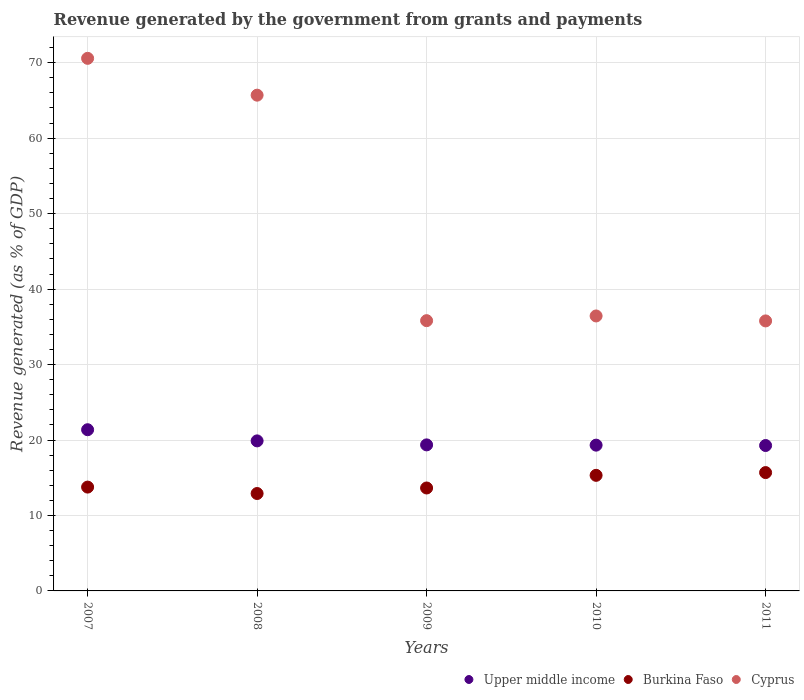How many different coloured dotlines are there?
Provide a short and direct response. 3. What is the revenue generated by the government in Upper middle income in 2011?
Your response must be concise. 19.27. Across all years, what is the maximum revenue generated by the government in Cyprus?
Offer a terse response. 70.58. Across all years, what is the minimum revenue generated by the government in Cyprus?
Give a very brief answer. 35.78. In which year was the revenue generated by the government in Upper middle income maximum?
Offer a terse response. 2007. In which year was the revenue generated by the government in Burkina Faso minimum?
Make the answer very short. 2008. What is the total revenue generated by the government in Upper middle income in the graph?
Provide a short and direct response. 99.19. What is the difference between the revenue generated by the government in Burkina Faso in 2010 and that in 2011?
Keep it short and to the point. -0.37. What is the difference between the revenue generated by the government in Burkina Faso in 2011 and the revenue generated by the government in Upper middle income in 2007?
Give a very brief answer. -5.68. What is the average revenue generated by the government in Cyprus per year?
Ensure brevity in your answer.  48.86. In the year 2007, what is the difference between the revenue generated by the government in Cyprus and revenue generated by the government in Burkina Faso?
Your answer should be compact. 56.82. What is the ratio of the revenue generated by the government in Upper middle income in 2007 to that in 2008?
Make the answer very short. 1.07. Is the revenue generated by the government in Upper middle income in 2007 less than that in 2010?
Your answer should be very brief. No. What is the difference between the highest and the second highest revenue generated by the government in Cyprus?
Make the answer very short. 4.88. What is the difference between the highest and the lowest revenue generated by the government in Upper middle income?
Ensure brevity in your answer.  2.09. In how many years, is the revenue generated by the government in Upper middle income greater than the average revenue generated by the government in Upper middle income taken over all years?
Your answer should be very brief. 2. Is it the case that in every year, the sum of the revenue generated by the government in Burkina Faso and revenue generated by the government in Upper middle income  is greater than the revenue generated by the government in Cyprus?
Provide a succinct answer. No. Is the revenue generated by the government in Burkina Faso strictly less than the revenue generated by the government in Cyprus over the years?
Provide a succinct answer. Yes. How many years are there in the graph?
Offer a very short reply. 5. What is the difference between two consecutive major ticks on the Y-axis?
Provide a short and direct response. 10. Are the values on the major ticks of Y-axis written in scientific E-notation?
Give a very brief answer. No. Does the graph contain any zero values?
Keep it short and to the point. No. How many legend labels are there?
Your response must be concise. 3. How are the legend labels stacked?
Your response must be concise. Horizontal. What is the title of the graph?
Make the answer very short. Revenue generated by the government from grants and payments. What is the label or title of the X-axis?
Your response must be concise. Years. What is the label or title of the Y-axis?
Offer a terse response. Revenue generated (as % of GDP). What is the Revenue generated (as % of GDP) of Upper middle income in 2007?
Provide a succinct answer. 21.36. What is the Revenue generated (as % of GDP) in Burkina Faso in 2007?
Offer a very short reply. 13.76. What is the Revenue generated (as % of GDP) in Cyprus in 2007?
Provide a succinct answer. 70.58. What is the Revenue generated (as % of GDP) of Upper middle income in 2008?
Provide a succinct answer. 19.88. What is the Revenue generated (as % of GDP) in Burkina Faso in 2008?
Your answer should be very brief. 12.91. What is the Revenue generated (as % of GDP) of Cyprus in 2008?
Your response must be concise. 65.7. What is the Revenue generated (as % of GDP) of Upper middle income in 2009?
Keep it short and to the point. 19.35. What is the Revenue generated (as % of GDP) of Burkina Faso in 2009?
Make the answer very short. 13.64. What is the Revenue generated (as % of GDP) in Cyprus in 2009?
Offer a very short reply. 35.82. What is the Revenue generated (as % of GDP) of Upper middle income in 2010?
Provide a short and direct response. 19.32. What is the Revenue generated (as % of GDP) in Burkina Faso in 2010?
Provide a short and direct response. 15.32. What is the Revenue generated (as % of GDP) in Cyprus in 2010?
Offer a terse response. 36.44. What is the Revenue generated (as % of GDP) of Upper middle income in 2011?
Ensure brevity in your answer.  19.27. What is the Revenue generated (as % of GDP) in Burkina Faso in 2011?
Offer a very short reply. 15.68. What is the Revenue generated (as % of GDP) in Cyprus in 2011?
Offer a terse response. 35.78. Across all years, what is the maximum Revenue generated (as % of GDP) of Upper middle income?
Your response must be concise. 21.36. Across all years, what is the maximum Revenue generated (as % of GDP) in Burkina Faso?
Provide a short and direct response. 15.68. Across all years, what is the maximum Revenue generated (as % of GDP) of Cyprus?
Ensure brevity in your answer.  70.58. Across all years, what is the minimum Revenue generated (as % of GDP) of Upper middle income?
Ensure brevity in your answer.  19.27. Across all years, what is the minimum Revenue generated (as % of GDP) of Burkina Faso?
Keep it short and to the point. 12.91. Across all years, what is the minimum Revenue generated (as % of GDP) of Cyprus?
Provide a short and direct response. 35.78. What is the total Revenue generated (as % of GDP) of Upper middle income in the graph?
Give a very brief answer. 99.19. What is the total Revenue generated (as % of GDP) of Burkina Faso in the graph?
Provide a short and direct response. 71.31. What is the total Revenue generated (as % of GDP) in Cyprus in the graph?
Offer a terse response. 244.32. What is the difference between the Revenue generated (as % of GDP) of Upper middle income in 2007 and that in 2008?
Your answer should be very brief. 1.48. What is the difference between the Revenue generated (as % of GDP) of Burkina Faso in 2007 and that in 2008?
Give a very brief answer. 0.85. What is the difference between the Revenue generated (as % of GDP) in Cyprus in 2007 and that in 2008?
Keep it short and to the point. 4.88. What is the difference between the Revenue generated (as % of GDP) in Upper middle income in 2007 and that in 2009?
Keep it short and to the point. 2.01. What is the difference between the Revenue generated (as % of GDP) of Burkina Faso in 2007 and that in 2009?
Offer a very short reply. 0.12. What is the difference between the Revenue generated (as % of GDP) of Cyprus in 2007 and that in 2009?
Provide a succinct answer. 34.77. What is the difference between the Revenue generated (as % of GDP) in Upper middle income in 2007 and that in 2010?
Provide a short and direct response. 2.04. What is the difference between the Revenue generated (as % of GDP) in Burkina Faso in 2007 and that in 2010?
Provide a succinct answer. -1.56. What is the difference between the Revenue generated (as % of GDP) in Cyprus in 2007 and that in 2010?
Your answer should be compact. 34.14. What is the difference between the Revenue generated (as % of GDP) in Upper middle income in 2007 and that in 2011?
Provide a succinct answer. 2.09. What is the difference between the Revenue generated (as % of GDP) of Burkina Faso in 2007 and that in 2011?
Offer a very short reply. -1.92. What is the difference between the Revenue generated (as % of GDP) in Cyprus in 2007 and that in 2011?
Ensure brevity in your answer.  34.8. What is the difference between the Revenue generated (as % of GDP) in Upper middle income in 2008 and that in 2009?
Make the answer very short. 0.53. What is the difference between the Revenue generated (as % of GDP) in Burkina Faso in 2008 and that in 2009?
Ensure brevity in your answer.  -0.73. What is the difference between the Revenue generated (as % of GDP) of Cyprus in 2008 and that in 2009?
Offer a very short reply. 29.88. What is the difference between the Revenue generated (as % of GDP) of Upper middle income in 2008 and that in 2010?
Provide a succinct answer. 0.56. What is the difference between the Revenue generated (as % of GDP) of Burkina Faso in 2008 and that in 2010?
Your answer should be compact. -2.41. What is the difference between the Revenue generated (as % of GDP) of Cyprus in 2008 and that in 2010?
Ensure brevity in your answer.  29.26. What is the difference between the Revenue generated (as % of GDP) in Upper middle income in 2008 and that in 2011?
Your answer should be very brief. 0.61. What is the difference between the Revenue generated (as % of GDP) of Burkina Faso in 2008 and that in 2011?
Keep it short and to the point. -2.77. What is the difference between the Revenue generated (as % of GDP) of Cyprus in 2008 and that in 2011?
Your answer should be very brief. 29.92. What is the difference between the Revenue generated (as % of GDP) in Upper middle income in 2009 and that in 2010?
Provide a short and direct response. 0.04. What is the difference between the Revenue generated (as % of GDP) of Burkina Faso in 2009 and that in 2010?
Your response must be concise. -1.68. What is the difference between the Revenue generated (as % of GDP) of Cyprus in 2009 and that in 2010?
Provide a short and direct response. -0.62. What is the difference between the Revenue generated (as % of GDP) in Upper middle income in 2009 and that in 2011?
Make the answer very short. 0.09. What is the difference between the Revenue generated (as % of GDP) in Burkina Faso in 2009 and that in 2011?
Make the answer very short. -2.04. What is the difference between the Revenue generated (as % of GDP) of Cyprus in 2009 and that in 2011?
Provide a succinct answer. 0.03. What is the difference between the Revenue generated (as % of GDP) in Upper middle income in 2010 and that in 2011?
Make the answer very short. 0.05. What is the difference between the Revenue generated (as % of GDP) of Burkina Faso in 2010 and that in 2011?
Offer a terse response. -0.37. What is the difference between the Revenue generated (as % of GDP) of Cyprus in 2010 and that in 2011?
Keep it short and to the point. 0.66. What is the difference between the Revenue generated (as % of GDP) of Upper middle income in 2007 and the Revenue generated (as % of GDP) of Burkina Faso in 2008?
Your response must be concise. 8.45. What is the difference between the Revenue generated (as % of GDP) of Upper middle income in 2007 and the Revenue generated (as % of GDP) of Cyprus in 2008?
Make the answer very short. -44.34. What is the difference between the Revenue generated (as % of GDP) in Burkina Faso in 2007 and the Revenue generated (as % of GDP) in Cyprus in 2008?
Your response must be concise. -51.94. What is the difference between the Revenue generated (as % of GDP) in Upper middle income in 2007 and the Revenue generated (as % of GDP) in Burkina Faso in 2009?
Provide a short and direct response. 7.72. What is the difference between the Revenue generated (as % of GDP) of Upper middle income in 2007 and the Revenue generated (as % of GDP) of Cyprus in 2009?
Your response must be concise. -14.45. What is the difference between the Revenue generated (as % of GDP) of Burkina Faso in 2007 and the Revenue generated (as % of GDP) of Cyprus in 2009?
Provide a succinct answer. -22.06. What is the difference between the Revenue generated (as % of GDP) of Upper middle income in 2007 and the Revenue generated (as % of GDP) of Burkina Faso in 2010?
Your answer should be compact. 6.04. What is the difference between the Revenue generated (as % of GDP) in Upper middle income in 2007 and the Revenue generated (as % of GDP) in Cyprus in 2010?
Make the answer very short. -15.08. What is the difference between the Revenue generated (as % of GDP) of Burkina Faso in 2007 and the Revenue generated (as % of GDP) of Cyprus in 2010?
Offer a terse response. -22.68. What is the difference between the Revenue generated (as % of GDP) of Upper middle income in 2007 and the Revenue generated (as % of GDP) of Burkina Faso in 2011?
Your answer should be compact. 5.68. What is the difference between the Revenue generated (as % of GDP) in Upper middle income in 2007 and the Revenue generated (as % of GDP) in Cyprus in 2011?
Give a very brief answer. -14.42. What is the difference between the Revenue generated (as % of GDP) of Burkina Faso in 2007 and the Revenue generated (as % of GDP) of Cyprus in 2011?
Offer a very short reply. -22.02. What is the difference between the Revenue generated (as % of GDP) in Upper middle income in 2008 and the Revenue generated (as % of GDP) in Burkina Faso in 2009?
Provide a short and direct response. 6.24. What is the difference between the Revenue generated (as % of GDP) of Upper middle income in 2008 and the Revenue generated (as % of GDP) of Cyprus in 2009?
Offer a very short reply. -15.93. What is the difference between the Revenue generated (as % of GDP) in Burkina Faso in 2008 and the Revenue generated (as % of GDP) in Cyprus in 2009?
Keep it short and to the point. -22.91. What is the difference between the Revenue generated (as % of GDP) in Upper middle income in 2008 and the Revenue generated (as % of GDP) in Burkina Faso in 2010?
Provide a succinct answer. 4.57. What is the difference between the Revenue generated (as % of GDP) of Upper middle income in 2008 and the Revenue generated (as % of GDP) of Cyprus in 2010?
Provide a succinct answer. -16.56. What is the difference between the Revenue generated (as % of GDP) in Burkina Faso in 2008 and the Revenue generated (as % of GDP) in Cyprus in 2010?
Give a very brief answer. -23.53. What is the difference between the Revenue generated (as % of GDP) of Upper middle income in 2008 and the Revenue generated (as % of GDP) of Burkina Faso in 2011?
Your answer should be compact. 4.2. What is the difference between the Revenue generated (as % of GDP) in Upper middle income in 2008 and the Revenue generated (as % of GDP) in Cyprus in 2011?
Make the answer very short. -15.9. What is the difference between the Revenue generated (as % of GDP) in Burkina Faso in 2008 and the Revenue generated (as % of GDP) in Cyprus in 2011?
Your response must be concise. -22.87. What is the difference between the Revenue generated (as % of GDP) in Upper middle income in 2009 and the Revenue generated (as % of GDP) in Burkina Faso in 2010?
Your answer should be compact. 4.04. What is the difference between the Revenue generated (as % of GDP) of Upper middle income in 2009 and the Revenue generated (as % of GDP) of Cyprus in 2010?
Offer a very short reply. -17.09. What is the difference between the Revenue generated (as % of GDP) in Burkina Faso in 2009 and the Revenue generated (as % of GDP) in Cyprus in 2010?
Offer a terse response. -22.8. What is the difference between the Revenue generated (as % of GDP) in Upper middle income in 2009 and the Revenue generated (as % of GDP) in Burkina Faso in 2011?
Provide a short and direct response. 3.67. What is the difference between the Revenue generated (as % of GDP) of Upper middle income in 2009 and the Revenue generated (as % of GDP) of Cyprus in 2011?
Ensure brevity in your answer.  -16.43. What is the difference between the Revenue generated (as % of GDP) in Burkina Faso in 2009 and the Revenue generated (as % of GDP) in Cyprus in 2011?
Give a very brief answer. -22.14. What is the difference between the Revenue generated (as % of GDP) in Upper middle income in 2010 and the Revenue generated (as % of GDP) in Burkina Faso in 2011?
Provide a succinct answer. 3.64. What is the difference between the Revenue generated (as % of GDP) in Upper middle income in 2010 and the Revenue generated (as % of GDP) in Cyprus in 2011?
Your answer should be compact. -16.46. What is the difference between the Revenue generated (as % of GDP) in Burkina Faso in 2010 and the Revenue generated (as % of GDP) in Cyprus in 2011?
Offer a terse response. -20.46. What is the average Revenue generated (as % of GDP) of Upper middle income per year?
Offer a very short reply. 19.84. What is the average Revenue generated (as % of GDP) in Burkina Faso per year?
Give a very brief answer. 14.26. What is the average Revenue generated (as % of GDP) of Cyprus per year?
Your response must be concise. 48.86. In the year 2007, what is the difference between the Revenue generated (as % of GDP) of Upper middle income and Revenue generated (as % of GDP) of Burkina Faso?
Your response must be concise. 7.6. In the year 2007, what is the difference between the Revenue generated (as % of GDP) in Upper middle income and Revenue generated (as % of GDP) in Cyprus?
Your answer should be very brief. -49.22. In the year 2007, what is the difference between the Revenue generated (as % of GDP) of Burkina Faso and Revenue generated (as % of GDP) of Cyprus?
Your answer should be compact. -56.82. In the year 2008, what is the difference between the Revenue generated (as % of GDP) of Upper middle income and Revenue generated (as % of GDP) of Burkina Faso?
Your response must be concise. 6.97. In the year 2008, what is the difference between the Revenue generated (as % of GDP) of Upper middle income and Revenue generated (as % of GDP) of Cyprus?
Make the answer very short. -45.82. In the year 2008, what is the difference between the Revenue generated (as % of GDP) in Burkina Faso and Revenue generated (as % of GDP) in Cyprus?
Your response must be concise. -52.79. In the year 2009, what is the difference between the Revenue generated (as % of GDP) of Upper middle income and Revenue generated (as % of GDP) of Burkina Faso?
Provide a short and direct response. 5.71. In the year 2009, what is the difference between the Revenue generated (as % of GDP) in Upper middle income and Revenue generated (as % of GDP) in Cyprus?
Your response must be concise. -16.46. In the year 2009, what is the difference between the Revenue generated (as % of GDP) in Burkina Faso and Revenue generated (as % of GDP) in Cyprus?
Provide a short and direct response. -22.17. In the year 2010, what is the difference between the Revenue generated (as % of GDP) of Upper middle income and Revenue generated (as % of GDP) of Burkina Faso?
Your answer should be compact. 4. In the year 2010, what is the difference between the Revenue generated (as % of GDP) in Upper middle income and Revenue generated (as % of GDP) in Cyprus?
Your answer should be compact. -17.12. In the year 2010, what is the difference between the Revenue generated (as % of GDP) of Burkina Faso and Revenue generated (as % of GDP) of Cyprus?
Provide a succinct answer. -21.12. In the year 2011, what is the difference between the Revenue generated (as % of GDP) in Upper middle income and Revenue generated (as % of GDP) in Burkina Faso?
Ensure brevity in your answer.  3.59. In the year 2011, what is the difference between the Revenue generated (as % of GDP) of Upper middle income and Revenue generated (as % of GDP) of Cyprus?
Make the answer very short. -16.51. In the year 2011, what is the difference between the Revenue generated (as % of GDP) in Burkina Faso and Revenue generated (as % of GDP) in Cyprus?
Provide a succinct answer. -20.1. What is the ratio of the Revenue generated (as % of GDP) of Upper middle income in 2007 to that in 2008?
Your answer should be very brief. 1.07. What is the ratio of the Revenue generated (as % of GDP) in Burkina Faso in 2007 to that in 2008?
Provide a short and direct response. 1.07. What is the ratio of the Revenue generated (as % of GDP) of Cyprus in 2007 to that in 2008?
Make the answer very short. 1.07. What is the ratio of the Revenue generated (as % of GDP) in Upper middle income in 2007 to that in 2009?
Ensure brevity in your answer.  1.1. What is the ratio of the Revenue generated (as % of GDP) in Burkina Faso in 2007 to that in 2009?
Ensure brevity in your answer.  1.01. What is the ratio of the Revenue generated (as % of GDP) in Cyprus in 2007 to that in 2009?
Offer a very short reply. 1.97. What is the ratio of the Revenue generated (as % of GDP) of Upper middle income in 2007 to that in 2010?
Make the answer very short. 1.11. What is the ratio of the Revenue generated (as % of GDP) in Burkina Faso in 2007 to that in 2010?
Provide a succinct answer. 0.9. What is the ratio of the Revenue generated (as % of GDP) of Cyprus in 2007 to that in 2010?
Offer a terse response. 1.94. What is the ratio of the Revenue generated (as % of GDP) in Upper middle income in 2007 to that in 2011?
Ensure brevity in your answer.  1.11. What is the ratio of the Revenue generated (as % of GDP) in Burkina Faso in 2007 to that in 2011?
Make the answer very short. 0.88. What is the ratio of the Revenue generated (as % of GDP) of Cyprus in 2007 to that in 2011?
Give a very brief answer. 1.97. What is the ratio of the Revenue generated (as % of GDP) of Upper middle income in 2008 to that in 2009?
Your answer should be compact. 1.03. What is the ratio of the Revenue generated (as % of GDP) in Burkina Faso in 2008 to that in 2009?
Offer a terse response. 0.95. What is the ratio of the Revenue generated (as % of GDP) in Cyprus in 2008 to that in 2009?
Provide a short and direct response. 1.83. What is the ratio of the Revenue generated (as % of GDP) in Upper middle income in 2008 to that in 2010?
Your answer should be very brief. 1.03. What is the ratio of the Revenue generated (as % of GDP) in Burkina Faso in 2008 to that in 2010?
Make the answer very short. 0.84. What is the ratio of the Revenue generated (as % of GDP) of Cyprus in 2008 to that in 2010?
Offer a terse response. 1.8. What is the ratio of the Revenue generated (as % of GDP) of Upper middle income in 2008 to that in 2011?
Your response must be concise. 1.03. What is the ratio of the Revenue generated (as % of GDP) in Burkina Faso in 2008 to that in 2011?
Offer a terse response. 0.82. What is the ratio of the Revenue generated (as % of GDP) of Cyprus in 2008 to that in 2011?
Provide a succinct answer. 1.84. What is the ratio of the Revenue generated (as % of GDP) of Upper middle income in 2009 to that in 2010?
Offer a very short reply. 1. What is the ratio of the Revenue generated (as % of GDP) in Burkina Faso in 2009 to that in 2010?
Provide a succinct answer. 0.89. What is the ratio of the Revenue generated (as % of GDP) of Cyprus in 2009 to that in 2010?
Your answer should be compact. 0.98. What is the ratio of the Revenue generated (as % of GDP) in Upper middle income in 2009 to that in 2011?
Provide a short and direct response. 1. What is the ratio of the Revenue generated (as % of GDP) in Burkina Faso in 2009 to that in 2011?
Keep it short and to the point. 0.87. What is the ratio of the Revenue generated (as % of GDP) in Upper middle income in 2010 to that in 2011?
Ensure brevity in your answer.  1. What is the ratio of the Revenue generated (as % of GDP) in Burkina Faso in 2010 to that in 2011?
Offer a very short reply. 0.98. What is the ratio of the Revenue generated (as % of GDP) of Cyprus in 2010 to that in 2011?
Your answer should be very brief. 1.02. What is the difference between the highest and the second highest Revenue generated (as % of GDP) of Upper middle income?
Make the answer very short. 1.48. What is the difference between the highest and the second highest Revenue generated (as % of GDP) in Burkina Faso?
Your answer should be compact. 0.37. What is the difference between the highest and the second highest Revenue generated (as % of GDP) in Cyprus?
Ensure brevity in your answer.  4.88. What is the difference between the highest and the lowest Revenue generated (as % of GDP) in Upper middle income?
Give a very brief answer. 2.09. What is the difference between the highest and the lowest Revenue generated (as % of GDP) of Burkina Faso?
Provide a short and direct response. 2.77. What is the difference between the highest and the lowest Revenue generated (as % of GDP) of Cyprus?
Your response must be concise. 34.8. 